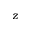Convert formula to latex. <formula><loc_0><loc_0><loc_500><loc_500>z</formula> 